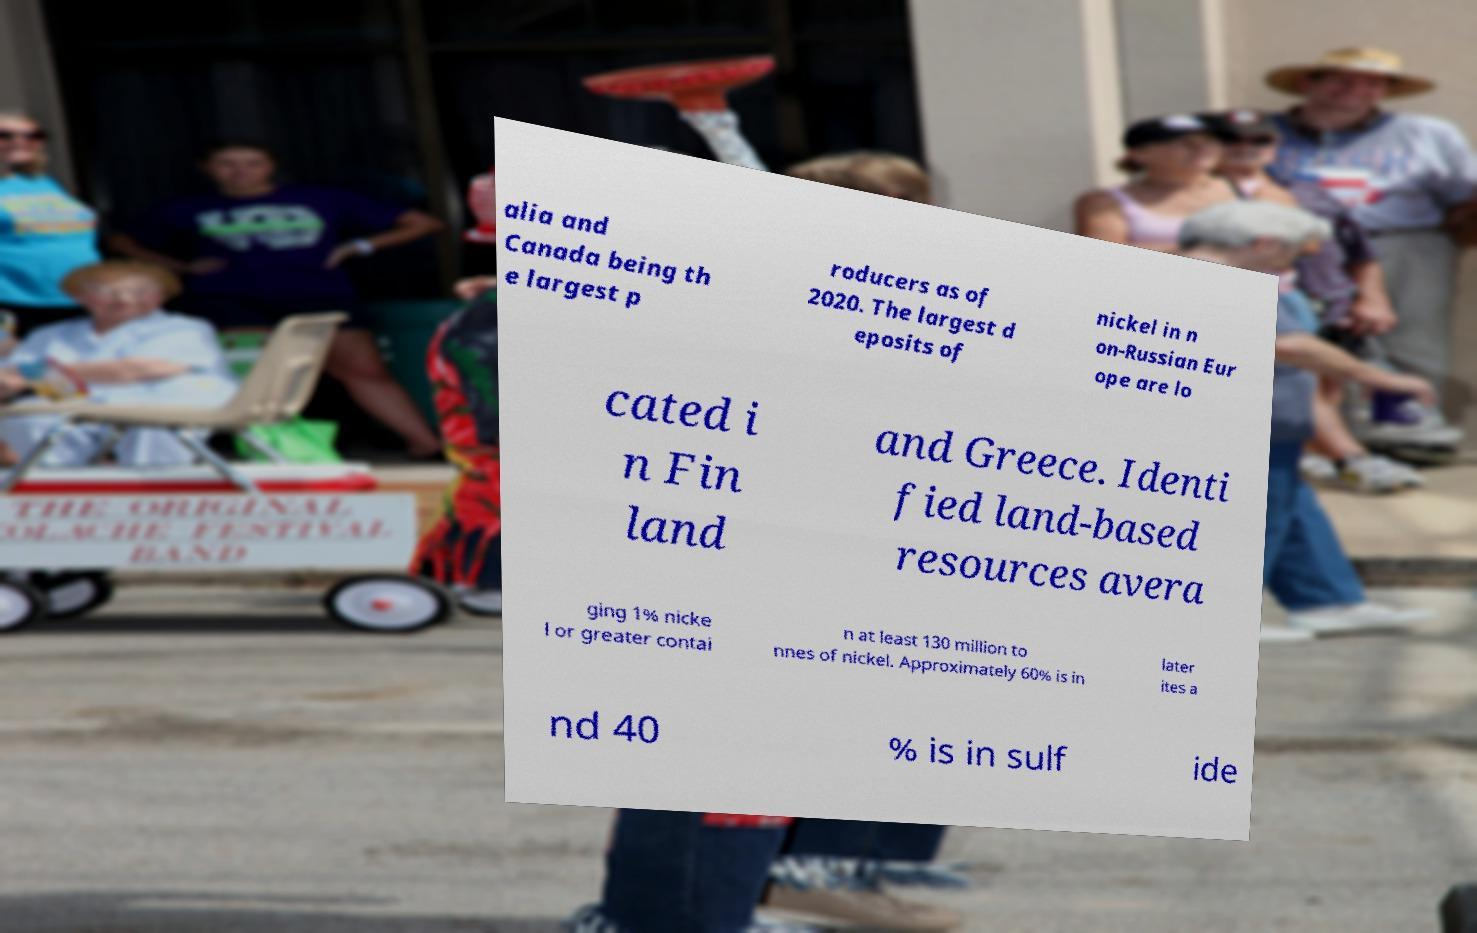For documentation purposes, I need the text within this image transcribed. Could you provide that? alia and Canada being th e largest p roducers as of 2020. The largest d eposits of nickel in n on-Russian Eur ope are lo cated i n Fin land and Greece. Identi fied land-based resources avera ging 1% nicke l or greater contai n at least 130 million to nnes of nickel. Approximately 60% is in later ites a nd 40 % is in sulf ide 